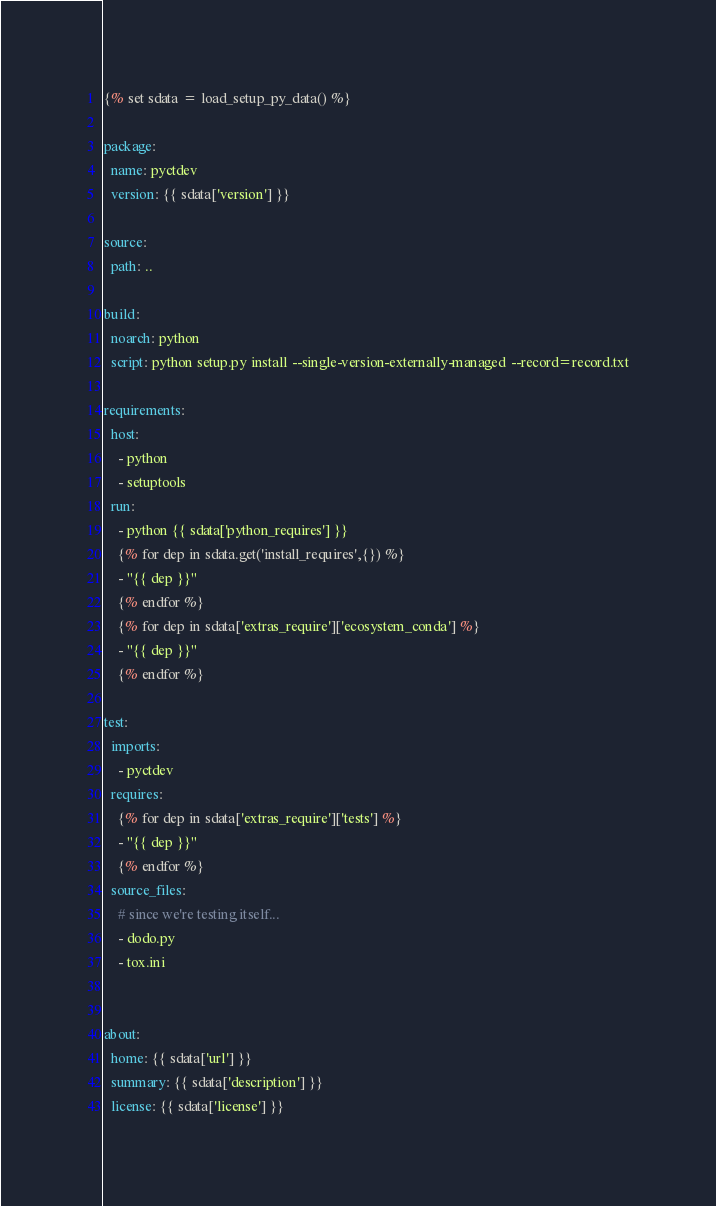<code> <loc_0><loc_0><loc_500><loc_500><_YAML_>{% set sdata = load_setup_py_data() %}

package:
  name: pyctdev
  version: {{ sdata['version'] }}

source:
  path: ..

build:
  noarch: python
  script: python setup.py install --single-version-externally-managed --record=record.txt

requirements:
  host:
    - python
    - setuptools
  run:
    - python {{ sdata['python_requires'] }}
    {% for dep in sdata.get('install_requires',{}) %}
    - "{{ dep }}"
    {% endfor %}
    {% for dep in sdata['extras_require']['ecosystem_conda'] %}
    - "{{ dep }}"
    {% endfor %}

test:
  imports:
    - pyctdev
  requires:
    {% for dep in sdata['extras_require']['tests'] %}
    - "{{ dep }}"
    {% endfor %}    
  source_files:
    # since we're testing itself...
    - dodo.py
    - tox.ini


about:
  home: {{ sdata['url'] }}
  summary: {{ sdata['description'] }}
  license: {{ sdata['license'] }}
</code> 